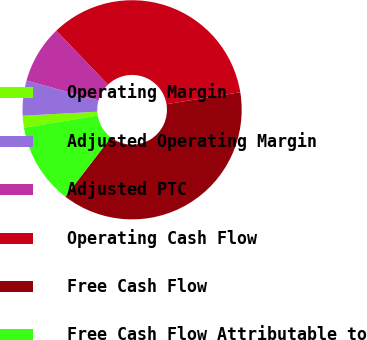<chart> <loc_0><loc_0><loc_500><loc_500><pie_chart><fcel>Operating Margin<fcel>Adjusted Operating Margin<fcel>Adjusted PTC<fcel>Operating Cash Flow<fcel>Free Cash Flow<fcel>Free Cash Flow Attributable to<nl><fcel>1.76%<fcel>5.16%<fcel>8.55%<fcel>34.59%<fcel>37.99%<fcel>11.95%<nl></chart> 